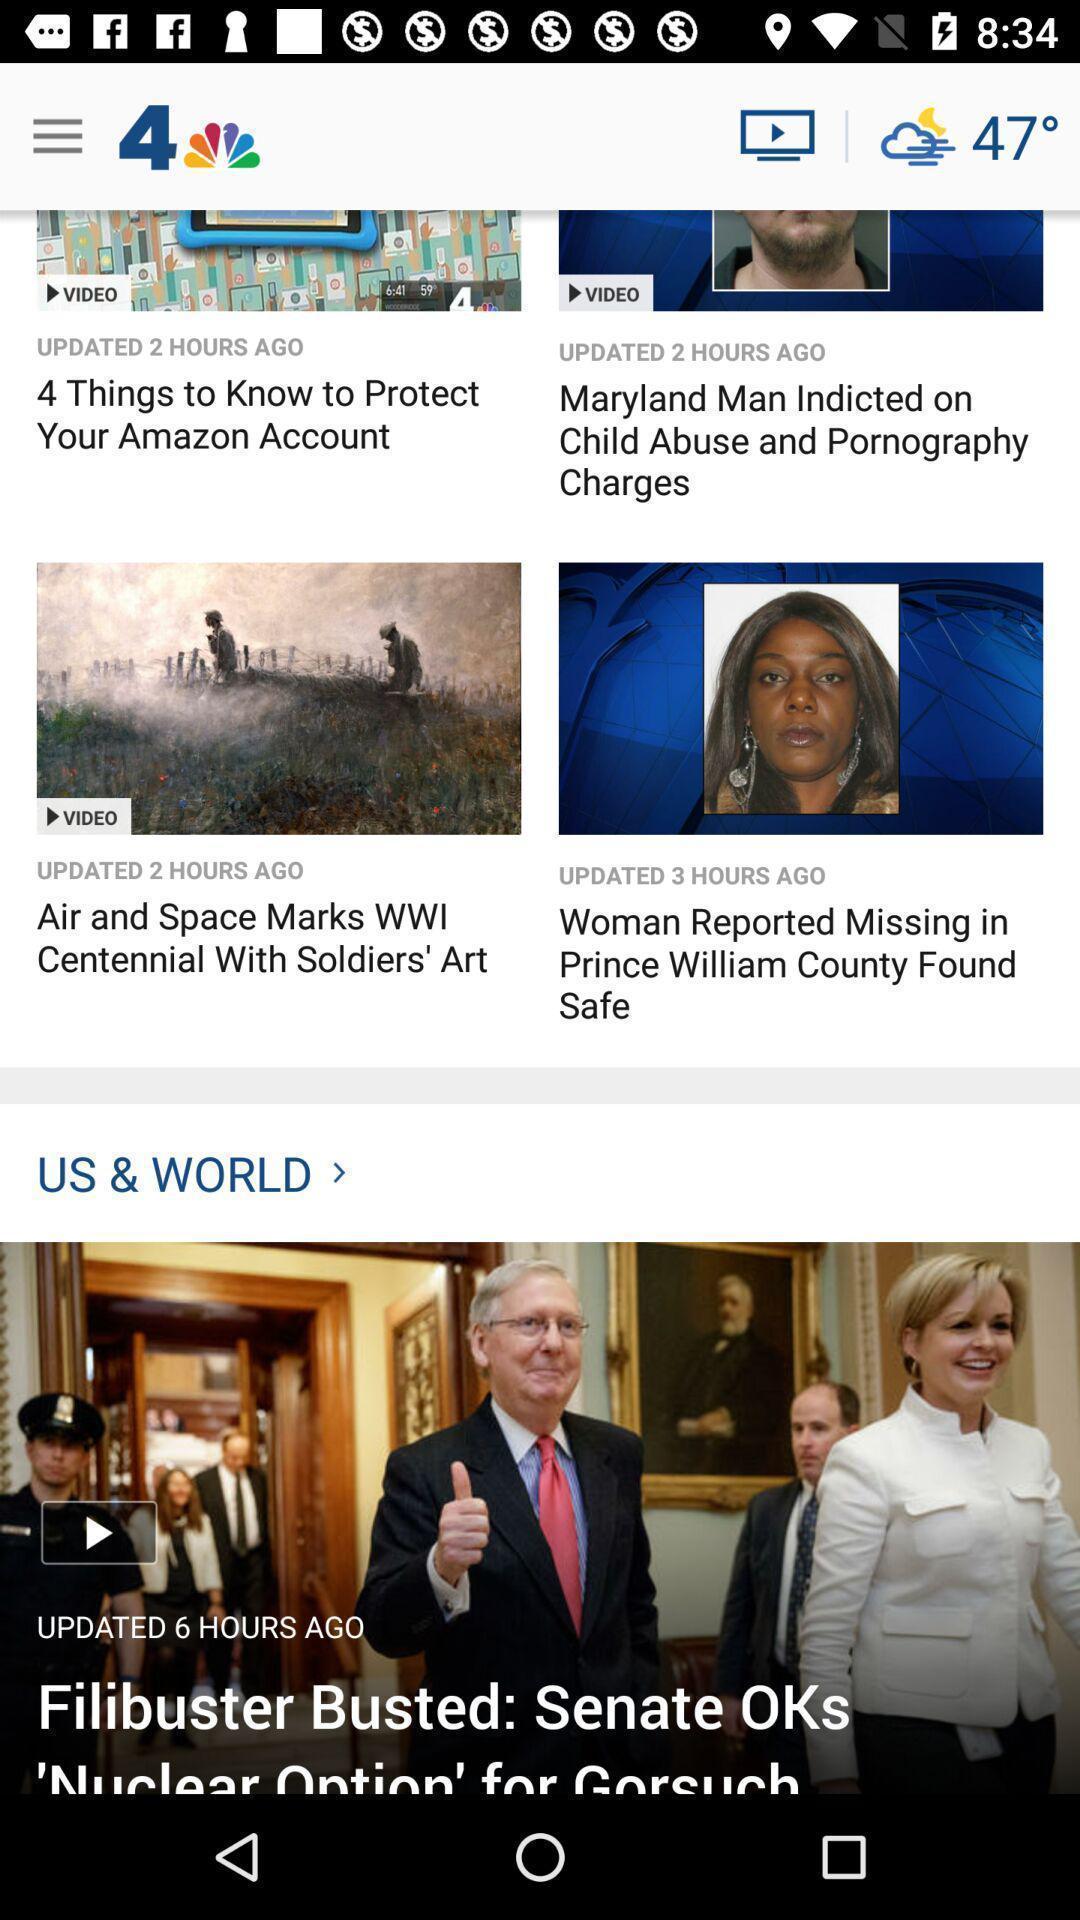Describe the key features of this screenshot. Page showing various articles in a news channel app. 